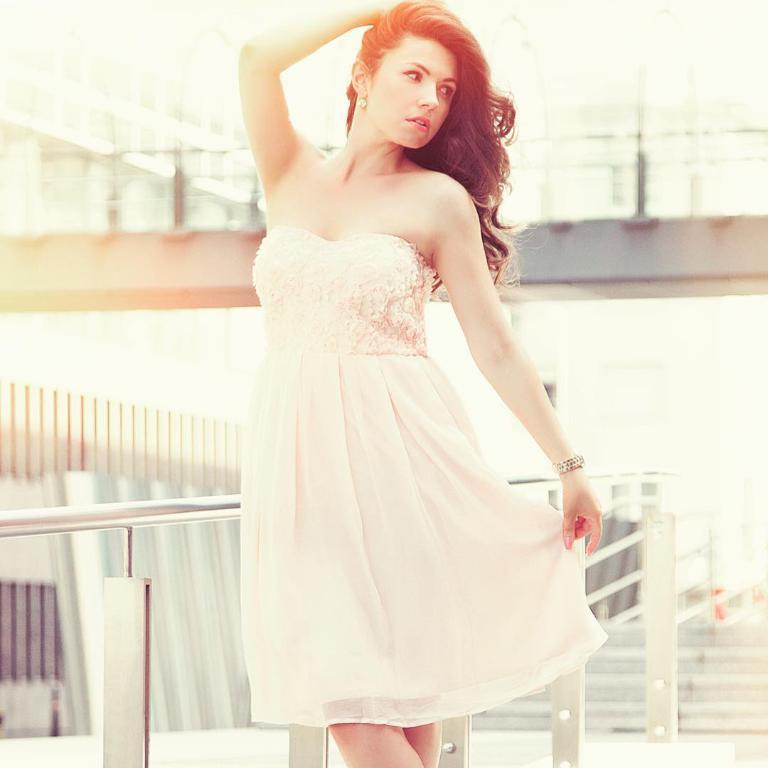What is the main subject of the image? There is a woman standing in the image. What architectural feature can be seen in the image? There are stairs visible in the image. What can be seen in the background of the image? There is a bridge in the background of the image. What structure is located on the left side of the image? There is a building on the left side of the image. What type of material is used for the rods in the image? There are metal rods to hold in the image. What type of ghost can be seen interacting with the woman in the image? There is no ghost present in the image; it only features a woman, stairs, a bridge, a building, and metal rods. How many clams are visible on the woman's clothing in the image? There are no clams present in the image; the woman is not wearing any clam-related items. 